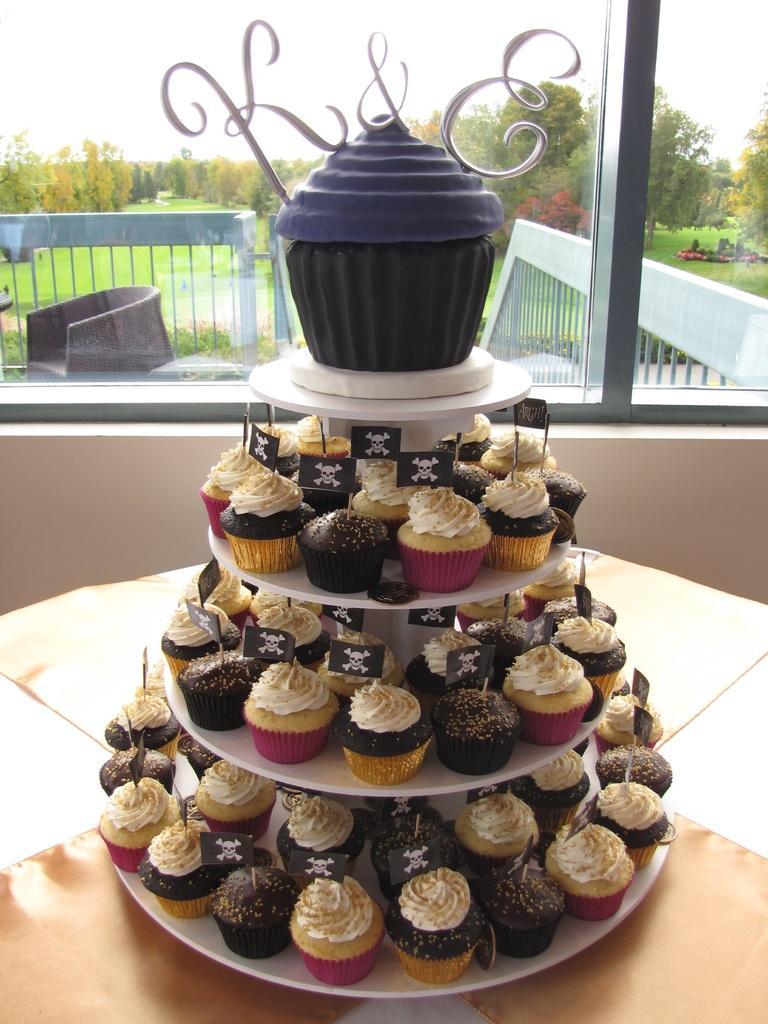Please provide a concise description of this image. In this image there is a table in which there is a steps stand. On the steps stand there are so many cupcakes. In the background there is a glass through which we can see the chairs and. On the right side we can see there are trees and ground. 